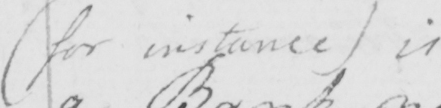Please provide the text content of this handwritten line. ( for instance )  is 